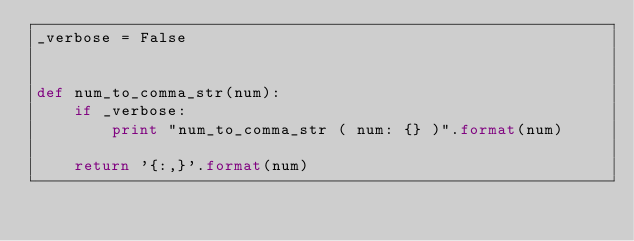<code> <loc_0><loc_0><loc_500><loc_500><_Python_>_verbose = False


def num_to_comma_str(num):
    if _verbose:
        print "num_to_comma_str ( num: {} )".format(num)

    return '{:,}'.format(num)
</code> 